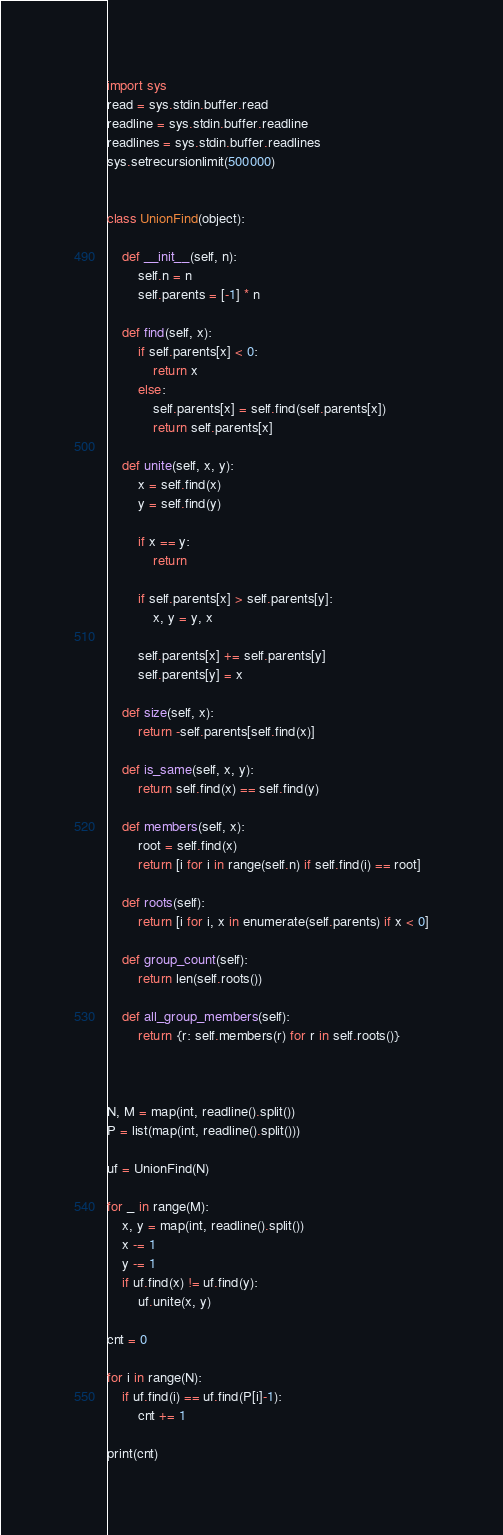Convert code to text. <code><loc_0><loc_0><loc_500><loc_500><_Python_>import sys
read = sys.stdin.buffer.read
readline = sys.stdin.buffer.readline
readlines = sys.stdin.buffer.readlines
sys.setrecursionlimit(500000)


class UnionFind(object):

    def __init__(self, n):
        self.n = n
        self.parents = [-1] * n

    def find(self, x):
        if self.parents[x] < 0:
            return x
        else:
            self.parents[x] = self.find(self.parents[x])
            return self.parents[x]

    def unite(self, x, y):
        x = self.find(x)
        y = self.find(y)

        if x == y:
            return

        if self.parents[x] > self.parents[y]:
            x, y = y, x

        self.parents[x] += self.parents[y]
        self.parents[y] = x

    def size(self, x):
        return -self.parents[self.find(x)]

    def is_same(self, x, y):
        return self.find(x) == self.find(y)

    def members(self, x):
        root = self.find(x)
        return [i for i in range(self.n) if self.find(i) == root]

    def roots(self):
        return [i for i, x in enumerate(self.parents) if x < 0]

    def group_count(self):
        return len(self.roots())

    def all_group_members(self):
        return {r: self.members(r) for r in self.roots()}



N, M = map(int, readline().split())
P = list(map(int, readline().split()))

uf = UnionFind(N)

for _ in range(M):
    x, y = map(int, readline().split())
    x -= 1
    y -= 1
    if uf.find(x) != uf.find(y):
        uf.unite(x, y)

cnt = 0

for i in range(N):
    if uf.find(i) == uf.find(P[i]-1):
        cnt += 1

print(cnt)
</code> 